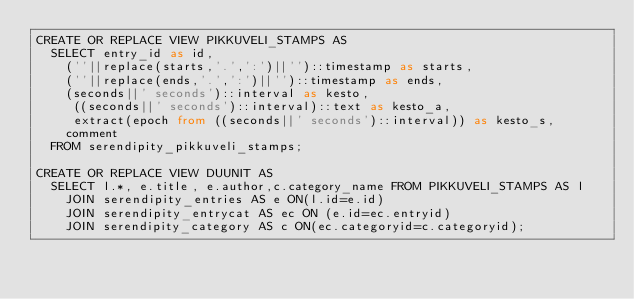<code> <loc_0><loc_0><loc_500><loc_500><_SQL_>CREATE OR REPLACE VIEW PIKKUVELI_STAMPS AS
	SELECT entry_id as id,
		(''||replace(starts,'.',':')||'')::timestamp as starts,
		(''||replace(ends,'.',':')||'')::timestamp as ends,
		(seconds||' seconds')::interval as kesto,
	   ((seconds||' seconds')::interval)::text as kesto_a,
	   extract(epoch from ((seconds||' seconds')::interval)) as kesto_s,
		comment 
	FROM serendipity_pikkuveli_stamps;

CREATE OR REPLACE VIEW DUUNIT AS 
  SELECT l.*, e.title, e.author,c.category_name FROM PIKKUVELI_STAMPS AS l 
    JOIN serendipity_entries AS e ON(l.id=e.id) 
    JOIN serendipity_entrycat AS ec ON (e.id=ec.entryid) 
    JOIN serendipity_category AS c ON(ec.categoryid=c.categoryid);
</code> 